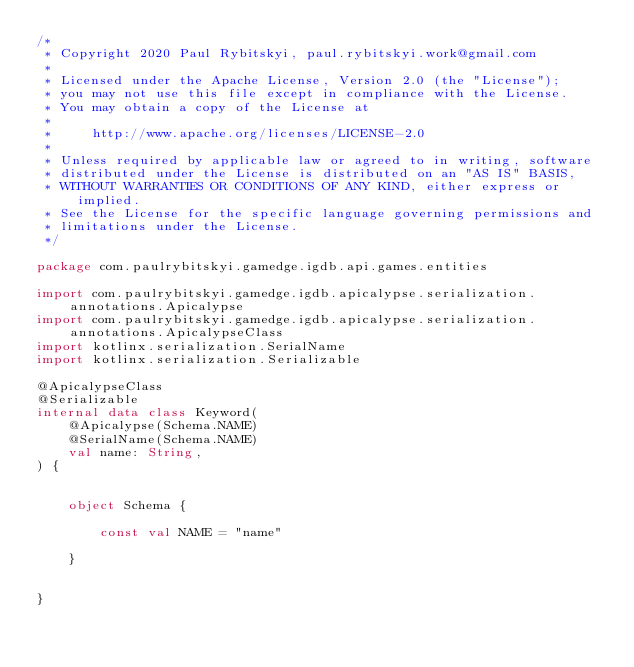<code> <loc_0><loc_0><loc_500><loc_500><_Kotlin_>/*
 * Copyright 2020 Paul Rybitskyi, paul.rybitskyi.work@gmail.com
 *
 * Licensed under the Apache License, Version 2.0 (the "License");
 * you may not use this file except in compliance with the License.
 * You may obtain a copy of the License at
 *
 *     http://www.apache.org/licenses/LICENSE-2.0
 *
 * Unless required by applicable law or agreed to in writing, software
 * distributed under the License is distributed on an "AS IS" BASIS,
 * WITHOUT WARRANTIES OR CONDITIONS OF ANY KIND, either express or implied.
 * See the License for the specific language governing permissions and
 * limitations under the License.
 */

package com.paulrybitskyi.gamedge.igdb.api.games.entities

import com.paulrybitskyi.gamedge.igdb.apicalypse.serialization.annotations.Apicalypse
import com.paulrybitskyi.gamedge.igdb.apicalypse.serialization.annotations.ApicalypseClass
import kotlinx.serialization.SerialName
import kotlinx.serialization.Serializable

@ApicalypseClass
@Serializable
internal data class Keyword(
    @Apicalypse(Schema.NAME)
    @SerialName(Schema.NAME)
    val name: String,
) {


    object Schema {

        const val NAME = "name"

    }


}</code> 